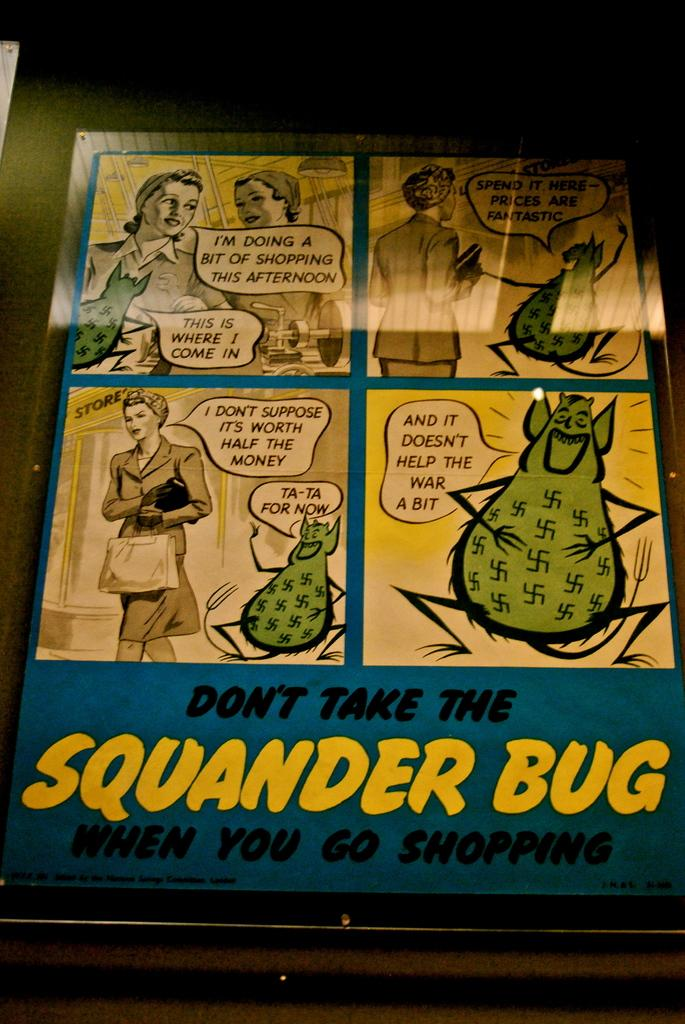<image>
Summarize the visual content of the image. A comic strip has Squander Bug in large yellow lettering below the comic. 